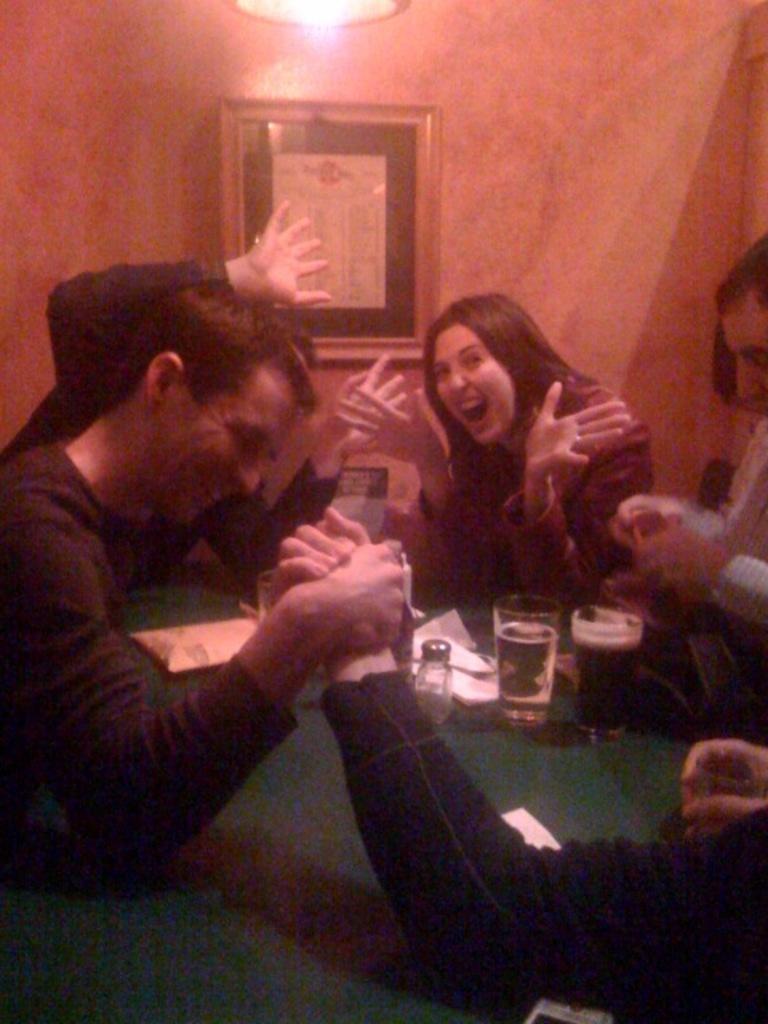Describe this image in one or two sentences. Here we can see some persons. This is table. On the table there are glasses, and papers. On the background there is a wall and this is frame. And there is a light. 